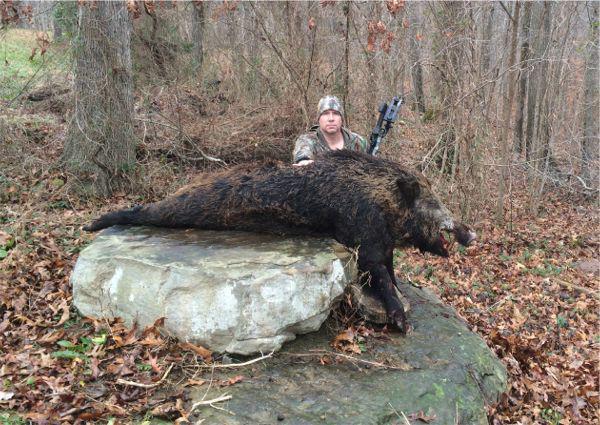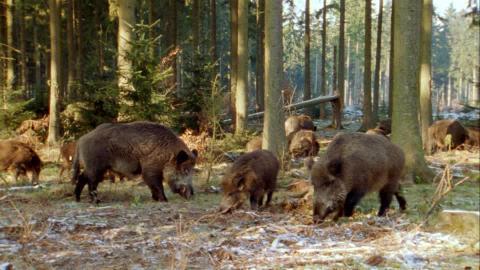The first image is the image on the left, the second image is the image on the right. For the images shown, is this caption "Each image contains a large rightward-facing boar and no left-facing boar, and in at least one image, the boar is dead and a hunter is posed behind it." true? Answer yes or no. No. The first image is the image on the left, the second image is the image on the right. For the images shown, is this caption "There is at least one hunter with their gun standing next to a dead boar." true? Answer yes or no. Yes. 